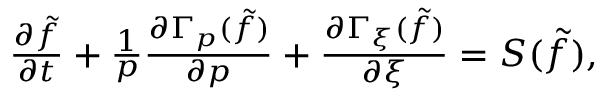Convert formula to latex. <formula><loc_0><loc_0><loc_500><loc_500>\begin{array} { r } { \frac { \partial \tilde { f } } { \partial t } + \frac { 1 } { p } \frac { \partial \Gamma _ { p } ( \tilde { f } ) } { \partial p } + \frac { \partial \Gamma _ { \xi } ( \tilde { f } ) } { \partial \xi } = S ( \tilde { f } ) , } \end{array}</formula> 